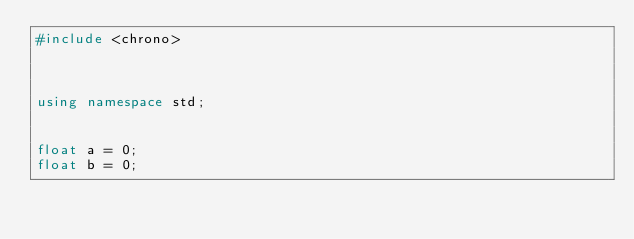<code> <loc_0><loc_0><loc_500><loc_500><_C++_>#include <chrono> 



using namespace std;


float a = 0;
float b = 0;</code> 